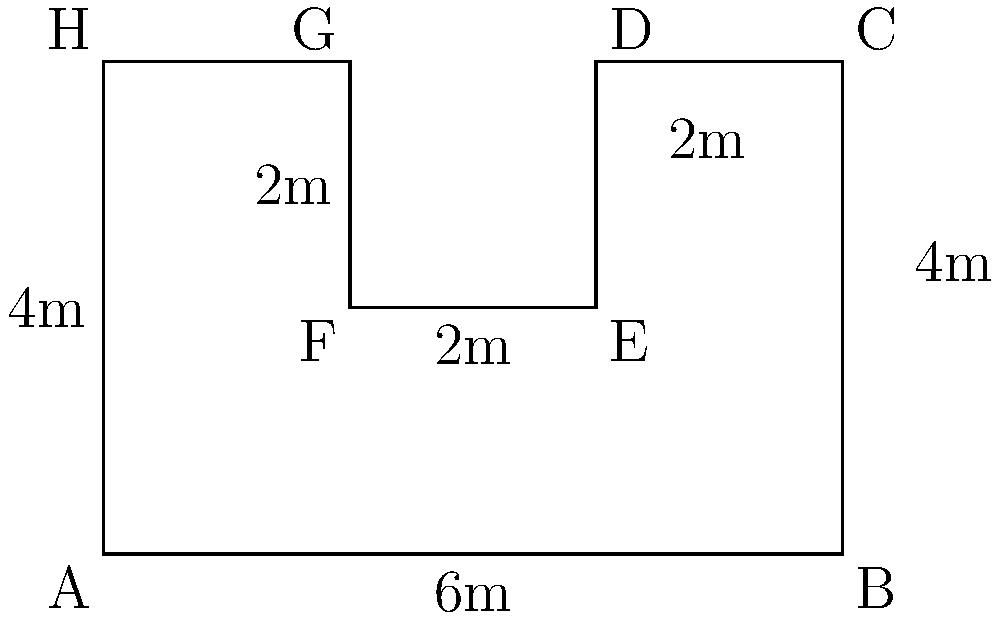You notice an irregular-shaped waiting area inside the Pontevedra Bus Station. The shape resembles a rectangle with two smaller rectangles removed from its top side. If the dimensions are as shown in the diagram (in meters), what is the perimeter of this waiting area? To find the perimeter, we need to sum up all the sides of the irregular shape:

1. Bottom side: $AB = 6$ m
2. Right side: $BC = 4$ m
3. Top right side: $CD = 2$ m
4. Right inner side: $DE = 2$ m
5. Top middle side: $EF = 2$ m
6. Left inner side: $FG = 2$ m
7. Top left side: $GH = 2$ m
8. Left side: $HA = 4$ m

Sum of all sides:
$$6 + 4 + 2 + 2 + 2 + 2 + 2 + 4 = 24$$

Therefore, the perimeter of the waiting area is 24 meters.
Answer: 24 meters 